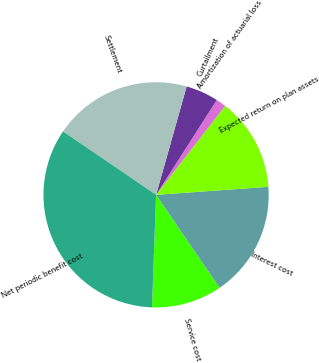Convert chart. <chart><loc_0><loc_0><loc_500><loc_500><pie_chart><fcel>Service cost<fcel>Interest cost<fcel>Expected return on plan assets<fcel>Amortization of actuarial loss<fcel>Curtailment<fcel>Settlement<fcel>Net periodic benefit cost<nl><fcel>10.11%<fcel>16.61%<fcel>13.36%<fcel>1.44%<fcel>4.69%<fcel>19.86%<fcel>33.94%<nl></chart> 